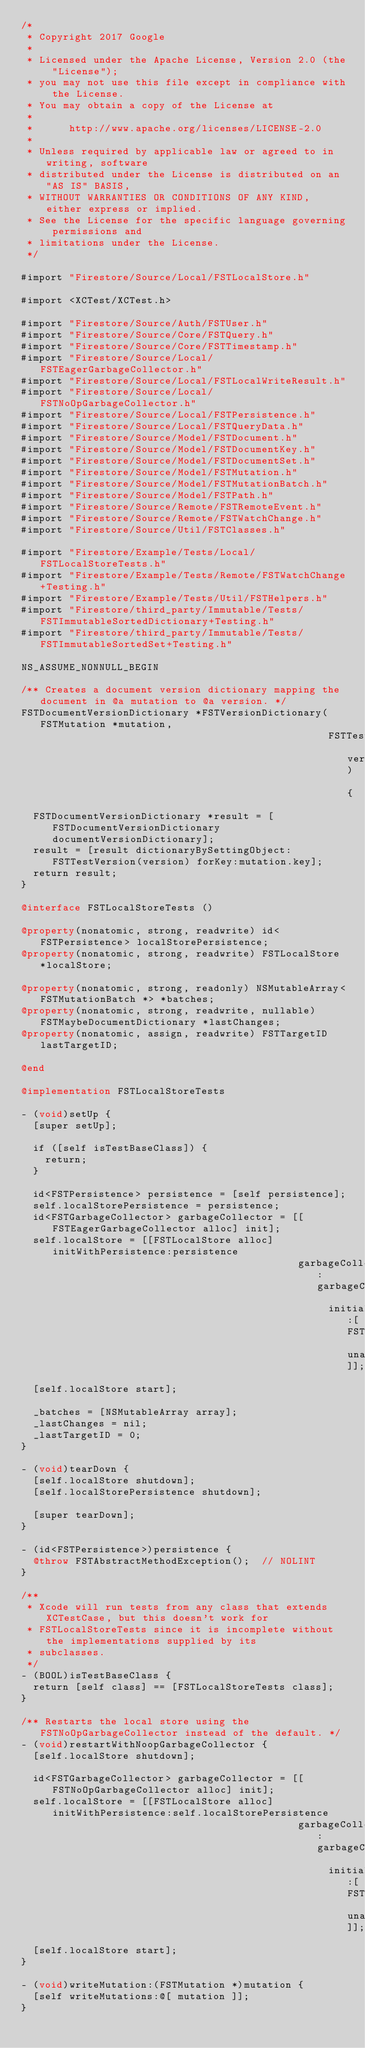<code> <loc_0><loc_0><loc_500><loc_500><_ObjectiveC_>/*
 * Copyright 2017 Google
 *
 * Licensed under the Apache License, Version 2.0 (the "License");
 * you may not use this file except in compliance with the License.
 * You may obtain a copy of the License at
 *
 *      http://www.apache.org/licenses/LICENSE-2.0
 *
 * Unless required by applicable law or agreed to in writing, software
 * distributed under the License is distributed on an "AS IS" BASIS,
 * WITHOUT WARRANTIES OR CONDITIONS OF ANY KIND, either express or implied.
 * See the License for the specific language governing permissions and
 * limitations under the License.
 */

#import "Firestore/Source/Local/FSTLocalStore.h"

#import <XCTest/XCTest.h>

#import "Firestore/Source/Auth/FSTUser.h"
#import "Firestore/Source/Core/FSTQuery.h"
#import "Firestore/Source/Core/FSTTimestamp.h"
#import "Firestore/Source/Local/FSTEagerGarbageCollector.h"
#import "Firestore/Source/Local/FSTLocalWriteResult.h"
#import "Firestore/Source/Local/FSTNoOpGarbageCollector.h"
#import "Firestore/Source/Local/FSTPersistence.h"
#import "Firestore/Source/Local/FSTQueryData.h"
#import "Firestore/Source/Model/FSTDocument.h"
#import "Firestore/Source/Model/FSTDocumentKey.h"
#import "Firestore/Source/Model/FSTDocumentSet.h"
#import "Firestore/Source/Model/FSTMutation.h"
#import "Firestore/Source/Model/FSTMutationBatch.h"
#import "Firestore/Source/Model/FSTPath.h"
#import "Firestore/Source/Remote/FSTRemoteEvent.h"
#import "Firestore/Source/Remote/FSTWatchChange.h"
#import "Firestore/Source/Util/FSTClasses.h"

#import "Firestore/Example/Tests/Local/FSTLocalStoreTests.h"
#import "Firestore/Example/Tests/Remote/FSTWatchChange+Testing.h"
#import "Firestore/Example/Tests/Util/FSTHelpers.h"
#import "Firestore/third_party/Immutable/Tests/FSTImmutableSortedDictionary+Testing.h"
#import "Firestore/third_party/Immutable/Tests/FSTImmutableSortedSet+Testing.h"

NS_ASSUME_NONNULL_BEGIN

/** Creates a document version dictionary mapping the document in @a mutation to @a version. */
FSTDocumentVersionDictionary *FSTVersionDictionary(FSTMutation *mutation,
                                                   FSTTestSnapshotVersion version) {
  FSTDocumentVersionDictionary *result = [FSTDocumentVersionDictionary documentVersionDictionary];
  result = [result dictionaryBySettingObject:FSTTestVersion(version) forKey:mutation.key];
  return result;
}

@interface FSTLocalStoreTests ()

@property(nonatomic, strong, readwrite) id<FSTPersistence> localStorePersistence;
@property(nonatomic, strong, readwrite) FSTLocalStore *localStore;

@property(nonatomic, strong, readonly) NSMutableArray<FSTMutationBatch *> *batches;
@property(nonatomic, strong, readwrite, nullable) FSTMaybeDocumentDictionary *lastChanges;
@property(nonatomic, assign, readwrite) FSTTargetID lastTargetID;

@end

@implementation FSTLocalStoreTests

- (void)setUp {
  [super setUp];

  if ([self isTestBaseClass]) {
    return;
  }

  id<FSTPersistence> persistence = [self persistence];
  self.localStorePersistence = persistence;
  id<FSTGarbageCollector> garbageCollector = [[FSTEagerGarbageCollector alloc] init];
  self.localStore = [[FSTLocalStore alloc] initWithPersistence:persistence
                                              garbageCollector:garbageCollector
                                                   initialUser:[FSTUser unauthenticatedUser]];
  [self.localStore start];

  _batches = [NSMutableArray array];
  _lastChanges = nil;
  _lastTargetID = 0;
}

- (void)tearDown {
  [self.localStore shutdown];
  [self.localStorePersistence shutdown];

  [super tearDown];
}

- (id<FSTPersistence>)persistence {
  @throw FSTAbstractMethodException();  // NOLINT
}

/**
 * Xcode will run tests from any class that extends XCTestCase, but this doesn't work for
 * FSTLocalStoreTests since it is incomplete without the implementations supplied by its
 * subclasses.
 */
- (BOOL)isTestBaseClass {
  return [self class] == [FSTLocalStoreTests class];
}

/** Restarts the local store using the FSTNoOpGarbageCollector instead of the default. */
- (void)restartWithNoopGarbageCollector {
  [self.localStore shutdown];

  id<FSTGarbageCollector> garbageCollector = [[FSTNoOpGarbageCollector alloc] init];
  self.localStore = [[FSTLocalStore alloc] initWithPersistence:self.localStorePersistence
                                              garbageCollector:garbageCollector
                                                   initialUser:[FSTUser unauthenticatedUser]];
  [self.localStore start];
}

- (void)writeMutation:(FSTMutation *)mutation {
  [self writeMutations:@[ mutation ]];
}
</code> 